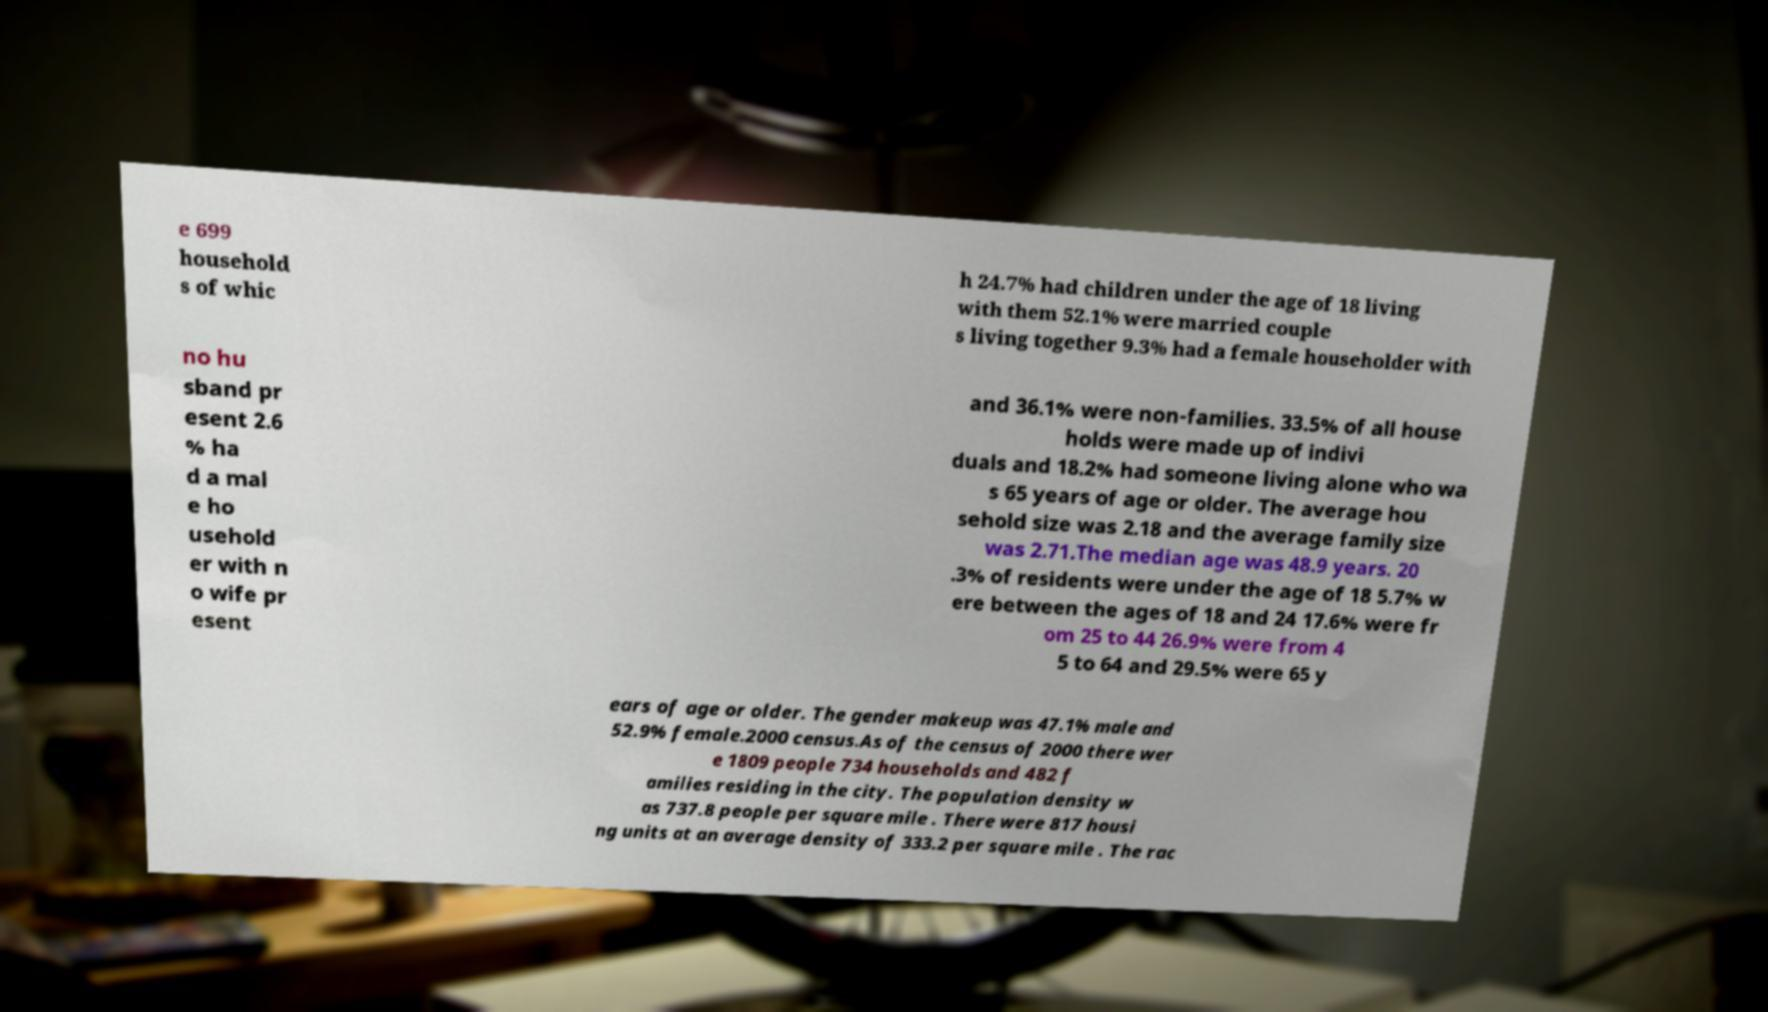There's text embedded in this image that I need extracted. Can you transcribe it verbatim? e 699 household s of whic h 24.7% had children under the age of 18 living with them 52.1% were married couple s living together 9.3% had a female householder with no hu sband pr esent 2.6 % ha d a mal e ho usehold er with n o wife pr esent and 36.1% were non-families. 33.5% of all house holds were made up of indivi duals and 18.2% had someone living alone who wa s 65 years of age or older. The average hou sehold size was 2.18 and the average family size was 2.71.The median age was 48.9 years. 20 .3% of residents were under the age of 18 5.7% w ere between the ages of 18 and 24 17.6% were fr om 25 to 44 26.9% were from 4 5 to 64 and 29.5% were 65 y ears of age or older. The gender makeup was 47.1% male and 52.9% female.2000 census.As of the census of 2000 there wer e 1809 people 734 households and 482 f amilies residing in the city. The population density w as 737.8 people per square mile . There were 817 housi ng units at an average density of 333.2 per square mile . The rac 